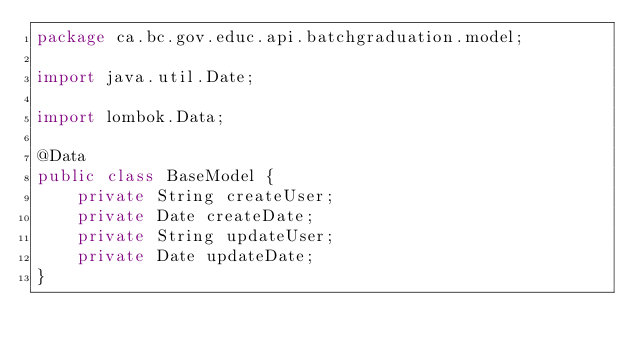Convert code to text. <code><loc_0><loc_0><loc_500><loc_500><_Java_>package ca.bc.gov.educ.api.batchgraduation.model;

import java.util.Date;

import lombok.Data;

@Data
public class BaseModel {
	private String createUser;
	private Date createDate;
	private String updateUser;
	private Date updateDate;
}
</code> 